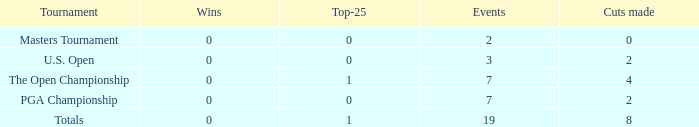Help me parse the entirety of this table. {'header': ['Tournament', 'Wins', 'Top-25', 'Events', 'Cuts made'], 'rows': [['Masters Tournament', '0', '0', '2', '0'], ['U.S. Open', '0', '0', '3', '2'], ['The Open Championship', '0', '1', '7', '4'], ['PGA Championship', '0', '0', '7', '2'], ['Totals', '0', '1', '19', '8']]} What are the success stories of the top-25 in 1 and 7 contests? 0.0. 